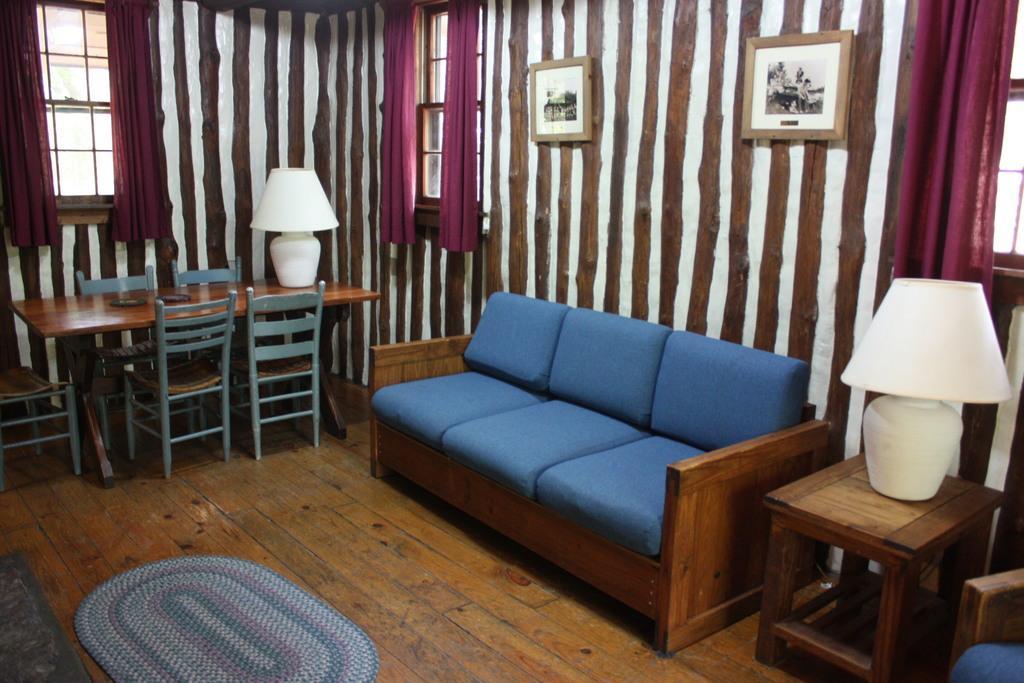Could you give a brief overview of what you see in this image? In this image I can see a sofa, few chairs, a table, two lamps and two frames on this wall. 